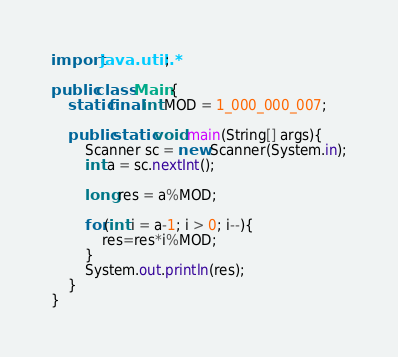<code> <loc_0><loc_0><loc_500><loc_500><_Java_>import java.util.*;

public class Main {
    static final int MOD = 1_000_000_007;
    
    public static void main(String[] args){
        Scanner sc = new Scanner(System.in);
        int a = sc.nextInt();
        
        long res = a%MOD;
        
        for(int i = a-1; i > 0; i--){
            res=res*i%MOD;
        }
        System.out.println(res);
    }
}
</code> 